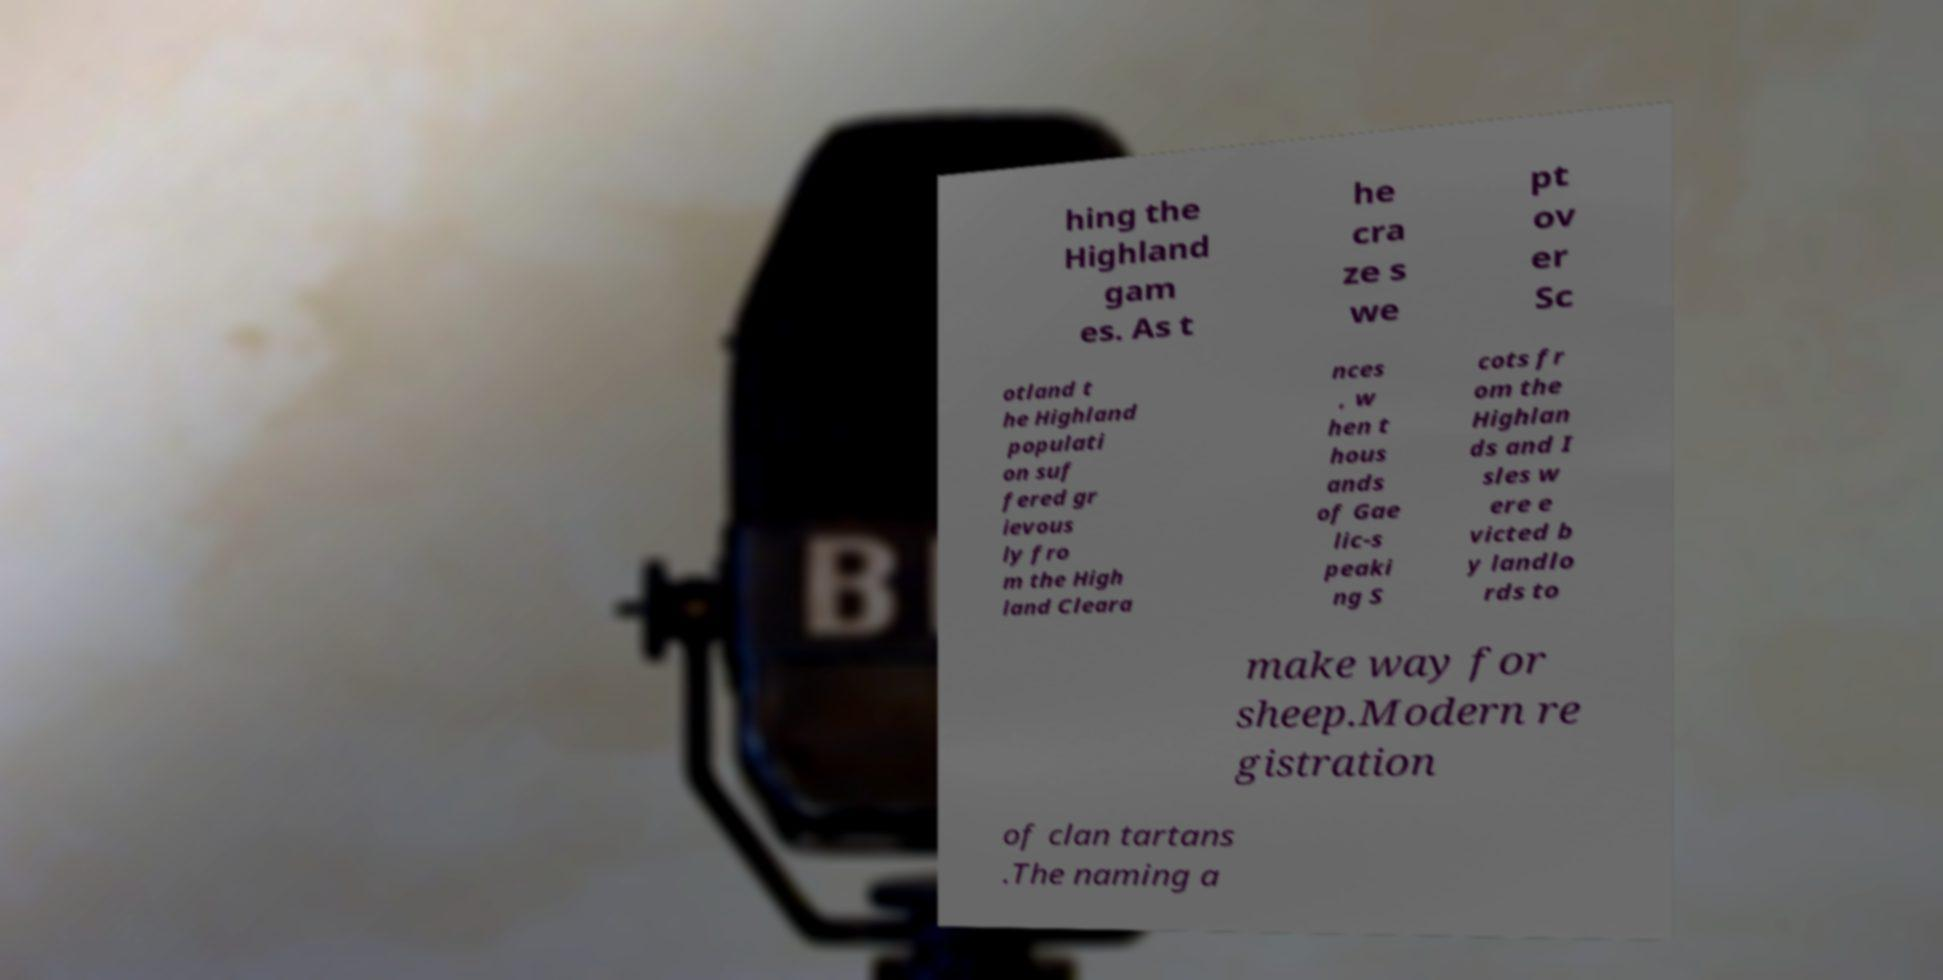Could you assist in decoding the text presented in this image and type it out clearly? hing the Highland gam es. As t he cra ze s we pt ov er Sc otland t he Highland populati on suf fered gr ievous ly fro m the High land Cleara nces , w hen t hous ands of Gae lic-s peaki ng S cots fr om the Highlan ds and I sles w ere e victed b y landlo rds to make way for sheep.Modern re gistration of clan tartans .The naming a 